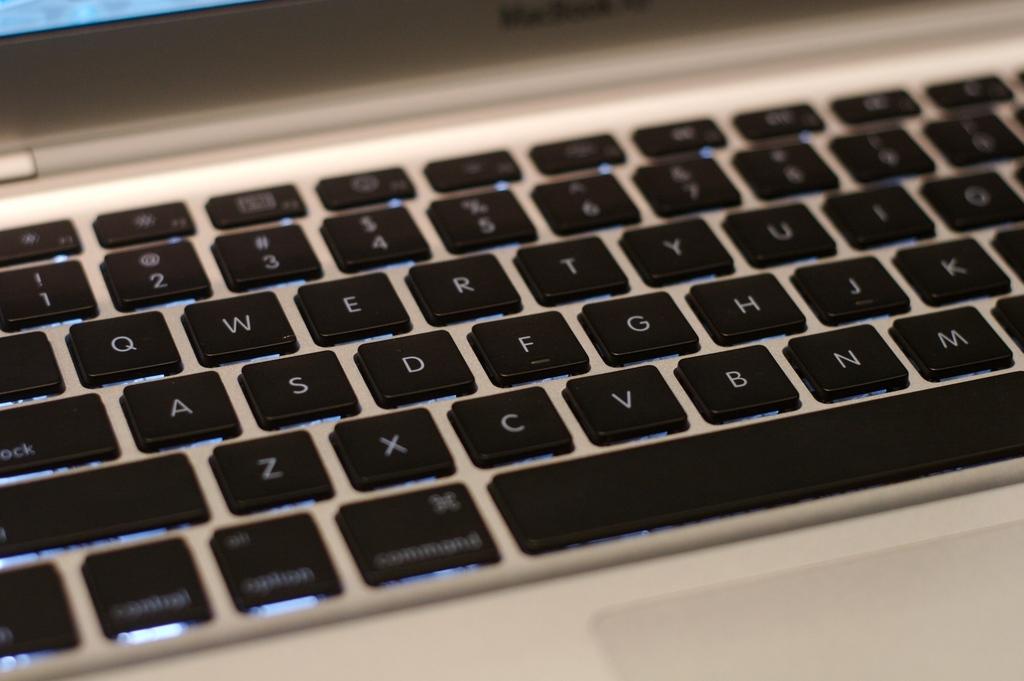Does this have a command key?
Your answer should be very brief. Yes. What type of laptop is this?
Make the answer very short. Unanswerable. 